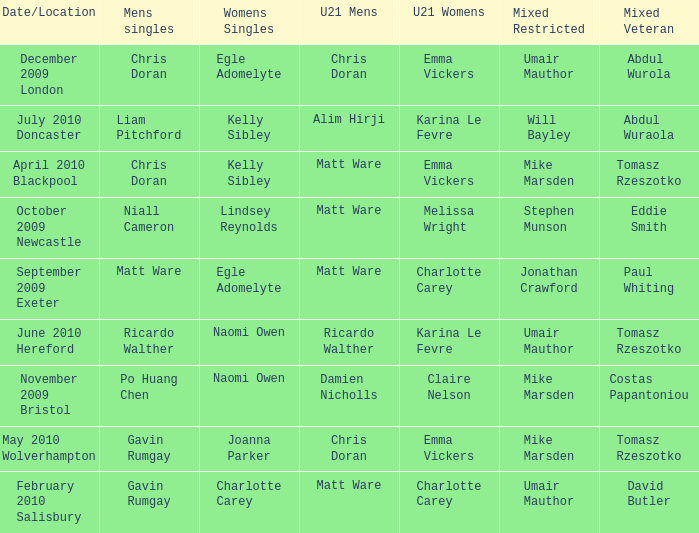When Paul Whiting won the mixed veteran, who won the mixed restricted? Jonathan Crawford. 